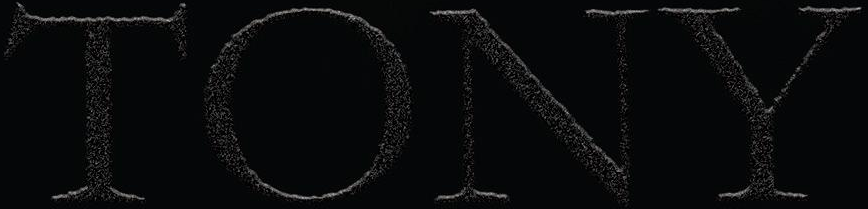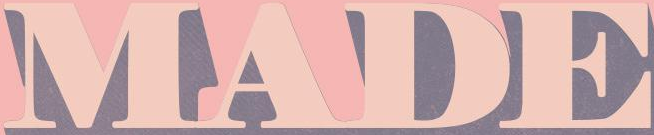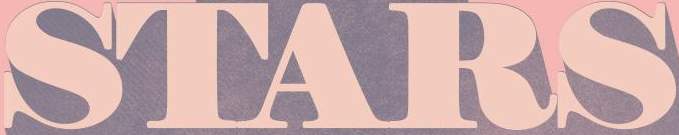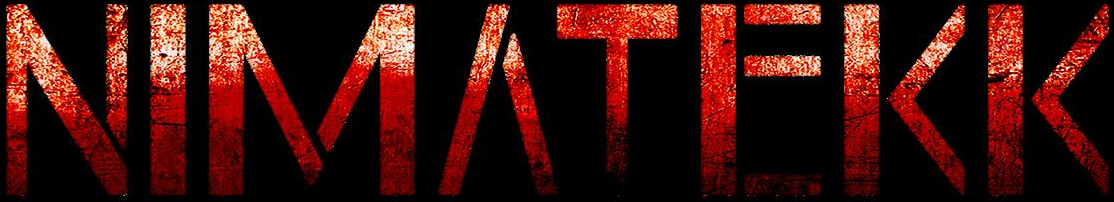What words are shown in these images in order, separated by a semicolon? TONY; MADE; STARS; NIMΛTEKK 